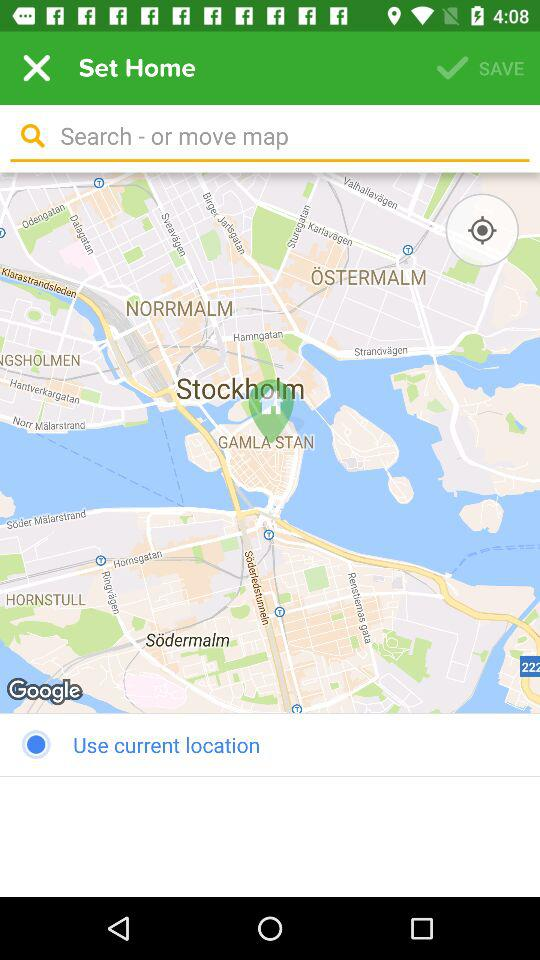Which location is chosen?
When the provided information is insufficient, respond with <no answer>. <no answer> 